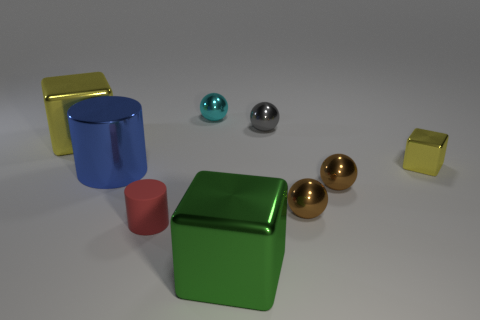Add 1 brown things. How many objects exist? 10 Subtract all blocks. How many objects are left? 6 Subtract 0 cyan cylinders. How many objects are left? 9 Subtract all tiny cyan cylinders. Subtract all tiny metal balls. How many objects are left? 5 Add 7 green metallic cubes. How many green metallic cubes are left? 8 Add 3 gray spheres. How many gray spheres exist? 4 